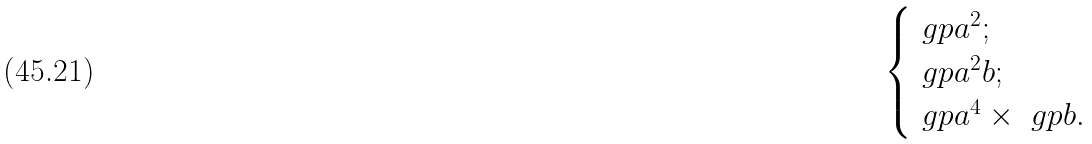<formula> <loc_0><loc_0><loc_500><loc_500>\begin{cases} \ g p { a ^ { 2 } } ; \\ \ g p { a ^ { 2 } b } ; \\ \ g p { a ^ { 4 } } \times \ g p { b } . \end{cases}</formula> 